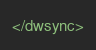<code> <loc_0><loc_0><loc_500><loc_500><_XML_></dwsync></code> 